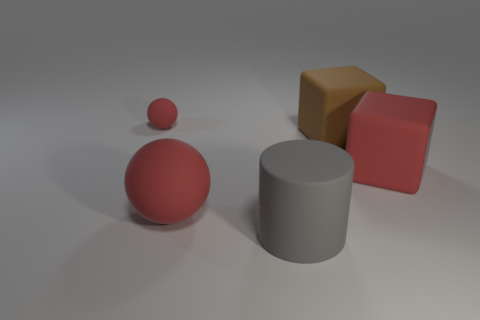Is there any other thing that has the same size as the gray cylinder?
Ensure brevity in your answer.  Yes. Are there any tiny objects that have the same color as the big rubber sphere?
Ensure brevity in your answer.  Yes. There is a big ball; is its color the same as the matte object behind the brown matte thing?
Keep it short and to the point. Yes. What is the size of the red object on the left side of the red ball that is in front of the red object right of the gray rubber thing?
Ensure brevity in your answer.  Small. Is there anything else that is the same shape as the large gray matte object?
Keep it short and to the point. No. What size is the red ball that is behind the ball in front of the tiny rubber ball?
Offer a very short reply. Small. How many tiny objects are brown things or cylinders?
Offer a terse response. 0. Are there fewer blue rubber cylinders than large gray matte objects?
Provide a short and direct response. Yes. Is the tiny matte sphere the same color as the large ball?
Provide a succinct answer. Yes. Are there more matte cubes than big cyan metallic blocks?
Keep it short and to the point. Yes. 